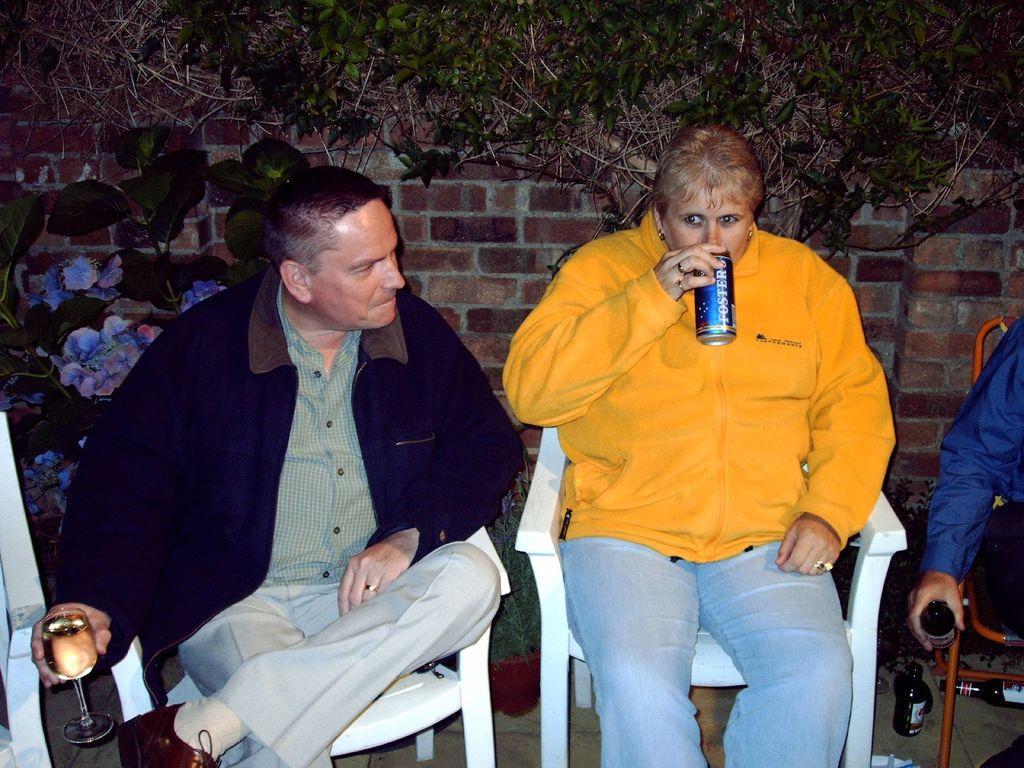How would you summarize this image in a sentence or two? On the left we can see a chair and a person is sitting on a chair by holding a wine glass in his hand and beside him there is a woman sitting on the chair by holding a tin in her hand. On the right we can see a person sitting on the chair by holding a wine bottle in the hand. On the ground we can see planets and wine bottles. In the background there are plants with flowers and wall. 